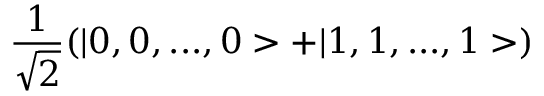Convert formula to latex. <formula><loc_0><loc_0><loc_500><loc_500>\frac { 1 } { \sqrt { 2 } } ( | 0 , 0 , \dots , 0 > + | 1 , 1 , \dots , 1 > )</formula> 